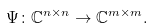<formula> <loc_0><loc_0><loc_500><loc_500>\Psi \colon \mathbb { C } ^ { n \times n } \rightarrow \mathbb { C } ^ { m \times m } .</formula> 